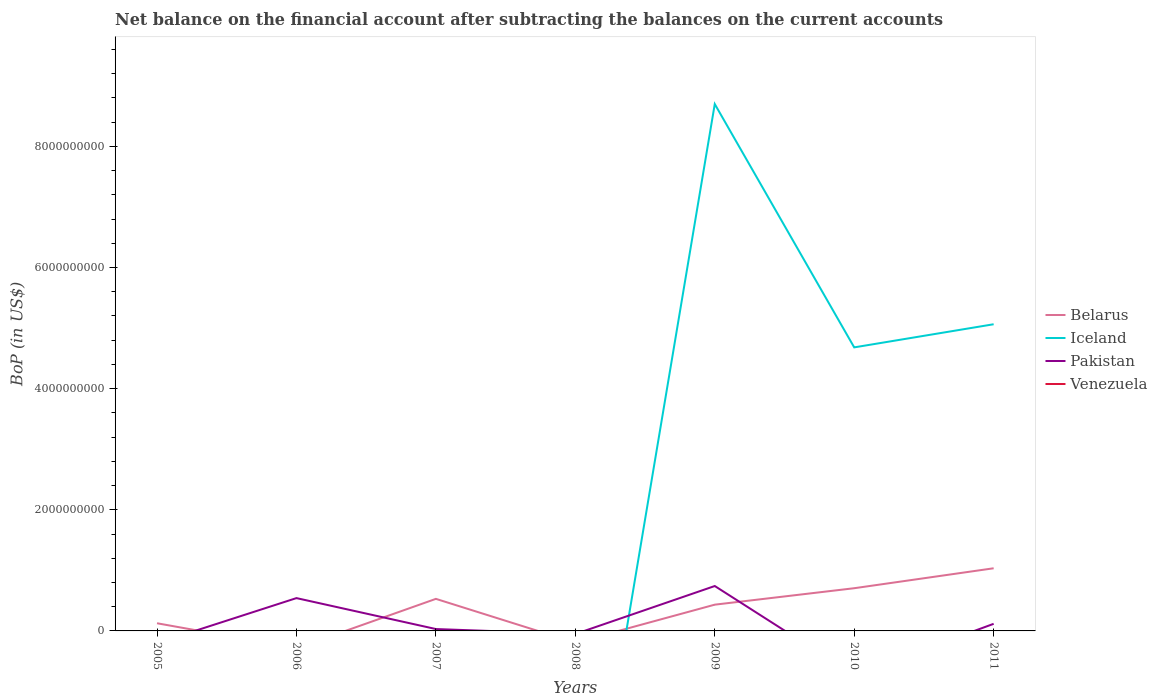How many different coloured lines are there?
Provide a succinct answer. 3. Does the line corresponding to Pakistan intersect with the line corresponding to Venezuela?
Your answer should be very brief. No. What is the total Balance of Payments in Pakistan in the graph?
Offer a very short reply. 6.24e+08. What is the difference between the highest and the second highest Balance of Payments in Iceland?
Your answer should be very brief. 8.70e+09. What is the difference between the highest and the lowest Balance of Payments in Venezuela?
Make the answer very short. 0. How many lines are there?
Offer a terse response. 3. How many years are there in the graph?
Make the answer very short. 7. What is the difference between two consecutive major ticks on the Y-axis?
Provide a succinct answer. 2.00e+09. Are the values on the major ticks of Y-axis written in scientific E-notation?
Keep it short and to the point. No. How are the legend labels stacked?
Offer a terse response. Vertical. What is the title of the graph?
Keep it short and to the point. Net balance on the financial account after subtracting the balances on the current accounts. What is the label or title of the X-axis?
Provide a short and direct response. Years. What is the label or title of the Y-axis?
Provide a short and direct response. BoP (in US$). What is the BoP (in US$) of Belarus in 2005?
Make the answer very short. 1.27e+08. What is the BoP (in US$) of Pakistan in 2005?
Provide a short and direct response. 0. What is the BoP (in US$) of Iceland in 2006?
Make the answer very short. 0. What is the BoP (in US$) in Pakistan in 2006?
Ensure brevity in your answer.  5.42e+08. What is the BoP (in US$) in Belarus in 2007?
Keep it short and to the point. 5.29e+08. What is the BoP (in US$) of Pakistan in 2007?
Make the answer very short. 3.10e+07. What is the BoP (in US$) in Pakistan in 2008?
Make the answer very short. 0. What is the BoP (in US$) in Venezuela in 2008?
Provide a short and direct response. 0. What is the BoP (in US$) in Belarus in 2009?
Offer a terse response. 4.34e+08. What is the BoP (in US$) of Iceland in 2009?
Provide a short and direct response. 8.70e+09. What is the BoP (in US$) of Pakistan in 2009?
Offer a terse response. 7.41e+08. What is the BoP (in US$) in Venezuela in 2009?
Ensure brevity in your answer.  0. What is the BoP (in US$) in Belarus in 2010?
Keep it short and to the point. 7.05e+08. What is the BoP (in US$) of Iceland in 2010?
Offer a very short reply. 4.68e+09. What is the BoP (in US$) of Belarus in 2011?
Give a very brief answer. 1.03e+09. What is the BoP (in US$) in Iceland in 2011?
Make the answer very short. 5.06e+09. What is the BoP (in US$) in Pakistan in 2011?
Provide a succinct answer. 1.17e+08. Across all years, what is the maximum BoP (in US$) of Belarus?
Provide a short and direct response. 1.03e+09. Across all years, what is the maximum BoP (in US$) in Iceland?
Make the answer very short. 8.70e+09. Across all years, what is the maximum BoP (in US$) of Pakistan?
Keep it short and to the point. 7.41e+08. Across all years, what is the minimum BoP (in US$) in Iceland?
Your response must be concise. 0. Across all years, what is the minimum BoP (in US$) of Pakistan?
Offer a terse response. 0. What is the total BoP (in US$) in Belarus in the graph?
Your response must be concise. 2.83e+09. What is the total BoP (in US$) of Iceland in the graph?
Keep it short and to the point. 1.84e+1. What is the total BoP (in US$) in Pakistan in the graph?
Ensure brevity in your answer.  1.43e+09. What is the total BoP (in US$) in Venezuela in the graph?
Your answer should be compact. 0. What is the difference between the BoP (in US$) in Belarus in 2005 and that in 2007?
Ensure brevity in your answer.  -4.03e+08. What is the difference between the BoP (in US$) in Belarus in 2005 and that in 2009?
Give a very brief answer. -3.07e+08. What is the difference between the BoP (in US$) of Belarus in 2005 and that in 2010?
Ensure brevity in your answer.  -5.78e+08. What is the difference between the BoP (in US$) of Belarus in 2005 and that in 2011?
Your answer should be very brief. -9.08e+08. What is the difference between the BoP (in US$) in Pakistan in 2006 and that in 2007?
Give a very brief answer. 5.11e+08. What is the difference between the BoP (in US$) in Pakistan in 2006 and that in 2009?
Make the answer very short. -2.00e+08. What is the difference between the BoP (in US$) in Pakistan in 2006 and that in 2011?
Offer a terse response. 4.25e+08. What is the difference between the BoP (in US$) in Belarus in 2007 and that in 2009?
Provide a succinct answer. 9.58e+07. What is the difference between the BoP (in US$) in Pakistan in 2007 and that in 2009?
Give a very brief answer. -7.10e+08. What is the difference between the BoP (in US$) of Belarus in 2007 and that in 2010?
Keep it short and to the point. -1.76e+08. What is the difference between the BoP (in US$) of Belarus in 2007 and that in 2011?
Your answer should be compact. -5.05e+08. What is the difference between the BoP (in US$) in Pakistan in 2007 and that in 2011?
Keep it short and to the point. -8.62e+07. What is the difference between the BoP (in US$) in Belarus in 2009 and that in 2010?
Make the answer very short. -2.72e+08. What is the difference between the BoP (in US$) of Iceland in 2009 and that in 2010?
Make the answer very short. 4.02e+09. What is the difference between the BoP (in US$) of Belarus in 2009 and that in 2011?
Offer a terse response. -6.01e+08. What is the difference between the BoP (in US$) of Iceland in 2009 and that in 2011?
Provide a short and direct response. 3.64e+09. What is the difference between the BoP (in US$) of Pakistan in 2009 and that in 2011?
Offer a terse response. 6.24e+08. What is the difference between the BoP (in US$) of Belarus in 2010 and that in 2011?
Provide a short and direct response. -3.29e+08. What is the difference between the BoP (in US$) in Iceland in 2010 and that in 2011?
Give a very brief answer. -3.82e+08. What is the difference between the BoP (in US$) in Belarus in 2005 and the BoP (in US$) in Pakistan in 2006?
Your response must be concise. -4.15e+08. What is the difference between the BoP (in US$) of Belarus in 2005 and the BoP (in US$) of Pakistan in 2007?
Ensure brevity in your answer.  9.56e+07. What is the difference between the BoP (in US$) of Belarus in 2005 and the BoP (in US$) of Iceland in 2009?
Keep it short and to the point. -8.57e+09. What is the difference between the BoP (in US$) of Belarus in 2005 and the BoP (in US$) of Pakistan in 2009?
Ensure brevity in your answer.  -6.15e+08. What is the difference between the BoP (in US$) in Belarus in 2005 and the BoP (in US$) in Iceland in 2010?
Offer a very short reply. -4.56e+09. What is the difference between the BoP (in US$) in Belarus in 2005 and the BoP (in US$) in Iceland in 2011?
Your response must be concise. -4.94e+09. What is the difference between the BoP (in US$) in Belarus in 2005 and the BoP (in US$) in Pakistan in 2011?
Keep it short and to the point. 9.35e+06. What is the difference between the BoP (in US$) of Belarus in 2007 and the BoP (in US$) of Iceland in 2009?
Provide a succinct answer. -8.17e+09. What is the difference between the BoP (in US$) in Belarus in 2007 and the BoP (in US$) in Pakistan in 2009?
Ensure brevity in your answer.  -2.12e+08. What is the difference between the BoP (in US$) in Belarus in 2007 and the BoP (in US$) in Iceland in 2010?
Keep it short and to the point. -4.15e+09. What is the difference between the BoP (in US$) in Belarus in 2007 and the BoP (in US$) in Iceland in 2011?
Your answer should be very brief. -4.53e+09. What is the difference between the BoP (in US$) in Belarus in 2007 and the BoP (in US$) in Pakistan in 2011?
Your answer should be compact. 4.12e+08. What is the difference between the BoP (in US$) of Belarus in 2009 and the BoP (in US$) of Iceland in 2010?
Your answer should be compact. -4.25e+09. What is the difference between the BoP (in US$) of Belarus in 2009 and the BoP (in US$) of Iceland in 2011?
Keep it short and to the point. -4.63e+09. What is the difference between the BoP (in US$) in Belarus in 2009 and the BoP (in US$) in Pakistan in 2011?
Offer a terse response. 3.16e+08. What is the difference between the BoP (in US$) in Iceland in 2009 and the BoP (in US$) in Pakistan in 2011?
Keep it short and to the point. 8.58e+09. What is the difference between the BoP (in US$) in Belarus in 2010 and the BoP (in US$) in Iceland in 2011?
Your answer should be very brief. -4.36e+09. What is the difference between the BoP (in US$) in Belarus in 2010 and the BoP (in US$) in Pakistan in 2011?
Ensure brevity in your answer.  5.88e+08. What is the difference between the BoP (in US$) of Iceland in 2010 and the BoP (in US$) of Pakistan in 2011?
Your response must be concise. 4.56e+09. What is the average BoP (in US$) of Belarus per year?
Ensure brevity in your answer.  4.04e+08. What is the average BoP (in US$) in Iceland per year?
Offer a terse response. 2.64e+09. What is the average BoP (in US$) in Pakistan per year?
Make the answer very short. 2.05e+08. What is the average BoP (in US$) of Venezuela per year?
Keep it short and to the point. 0. In the year 2007, what is the difference between the BoP (in US$) in Belarus and BoP (in US$) in Pakistan?
Offer a very short reply. 4.98e+08. In the year 2009, what is the difference between the BoP (in US$) in Belarus and BoP (in US$) in Iceland?
Keep it short and to the point. -8.27e+09. In the year 2009, what is the difference between the BoP (in US$) of Belarus and BoP (in US$) of Pakistan?
Provide a short and direct response. -3.08e+08. In the year 2009, what is the difference between the BoP (in US$) of Iceland and BoP (in US$) of Pakistan?
Offer a terse response. 7.96e+09. In the year 2010, what is the difference between the BoP (in US$) in Belarus and BoP (in US$) in Iceland?
Your response must be concise. -3.98e+09. In the year 2011, what is the difference between the BoP (in US$) of Belarus and BoP (in US$) of Iceland?
Keep it short and to the point. -4.03e+09. In the year 2011, what is the difference between the BoP (in US$) in Belarus and BoP (in US$) in Pakistan?
Keep it short and to the point. 9.17e+08. In the year 2011, what is the difference between the BoP (in US$) in Iceland and BoP (in US$) in Pakistan?
Your answer should be compact. 4.95e+09. What is the ratio of the BoP (in US$) of Belarus in 2005 to that in 2007?
Keep it short and to the point. 0.24. What is the ratio of the BoP (in US$) in Belarus in 2005 to that in 2009?
Provide a short and direct response. 0.29. What is the ratio of the BoP (in US$) in Belarus in 2005 to that in 2010?
Your response must be concise. 0.18. What is the ratio of the BoP (in US$) in Belarus in 2005 to that in 2011?
Your answer should be very brief. 0.12. What is the ratio of the BoP (in US$) in Pakistan in 2006 to that in 2007?
Your answer should be very brief. 17.48. What is the ratio of the BoP (in US$) in Pakistan in 2006 to that in 2009?
Give a very brief answer. 0.73. What is the ratio of the BoP (in US$) of Pakistan in 2006 to that in 2011?
Make the answer very short. 4.62. What is the ratio of the BoP (in US$) of Belarus in 2007 to that in 2009?
Offer a terse response. 1.22. What is the ratio of the BoP (in US$) in Pakistan in 2007 to that in 2009?
Provide a short and direct response. 0.04. What is the ratio of the BoP (in US$) in Belarus in 2007 to that in 2010?
Give a very brief answer. 0.75. What is the ratio of the BoP (in US$) of Belarus in 2007 to that in 2011?
Give a very brief answer. 0.51. What is the ratio of the BoP (in US$) in Pakistan in 2007 to that in 2011?
Provide a short and direct response. 0.26. What is the ratio of the BoP (in US$) in Belarus in 2009 to that in 2010?
Give a very brief answer. 0.61. What is the ratio of the BoP (in US$) of Iceland in 2009 to that in 2010?
Ensure brevity in your answer.  1.86. What is the ratio of the BoP (in US$) in Belarus in 2009 to that in 2011?
Your answer should be compact. 0.42. What is the ratio of the BoP (in US$) in Iceland in 2009 to that in 2011?
Ensure brevity in your answer.  1.72. What is the ratio of the BoP (in US$) of Pakistan in 2009 to that in 2011?
Your answer should be very brief. 6.32. What is the ratio of the BoP (in US$) of Belarus in 2010 to that in 2011?
Offer a very short reply. 0.68. What is the ratio of the BoP (in US$) in Iceland in 2010 to that in 2011?
Offer a terse response. 0.92. What is the difference between the highest and the second highest BoP (in US$) in Belarus?
Your response must be concise. 3.29e+08. What is the difference between the highest and the second highest BoP (in US$) of Iceland?
Your answer should be very brief. 3.64e+09. What is the difference between the highest and the second highest BoP (in US$) of Pakistan?
Make the answer very short. 2.00e+08. What is the difference between the highest and the lowest BoP (in US$) of Belarus?
Offer a very short reply. 1.03e+09. What is the difference between the highest and the lowest BoP (in US$) of Iceland?
Your answer should be compact. 8.70e+09. What is the difference between the highest and the lowest BoP (in US$) in Pakistan?
Ensure brevity in your answer.  7.41e+08. 